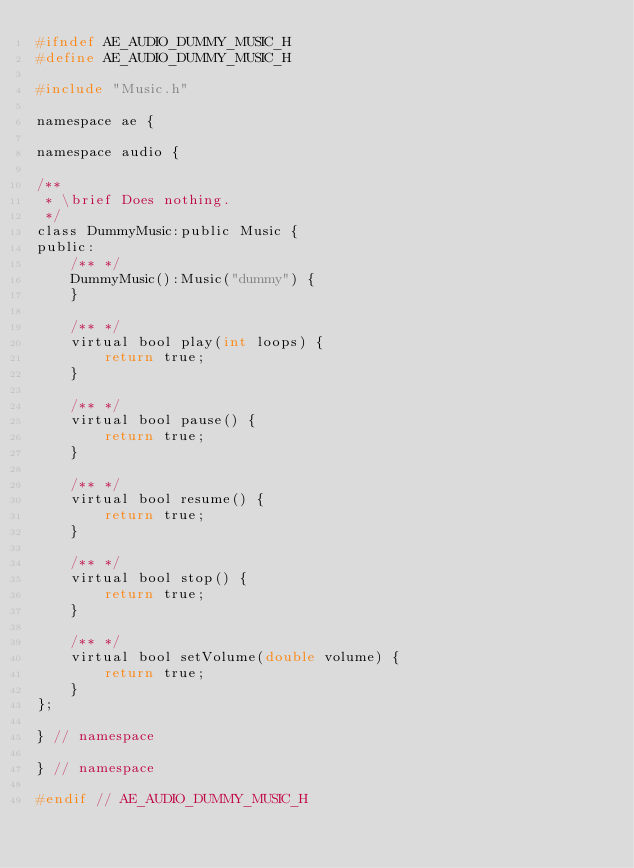<code> <loc_0><loc_0><loc_500><loc_500><_C_>#ifndef AE_AUDIO_DUMMY_MUSIC_H
#define AE_AUDIO_DUMMY_MUSIC_H

#include "Music.h"

namespace ae {

namespace audio {
  
/**
 * \brief Does nothing.
 */
class DummyMusic:public Music {
public:
    /** */
    DummyMusic():Music("dummy") {
    }
    
    /** */
    virtual bool play(int loops) {
        return true;
    }
    
    /** */
    virtual bool pause() {
        return true;
    }
    
    /** */
    virtual bool resume() {
        return true;
    }
    
    /** */
    virtual bool stop() {
        return true;
    }
    
    /** */
    virtual bool setVolume(double volume) {
        return true;
    }
};
    
} // namespace
    
} // namespace

#endif // AE_AUDIO_DUMMY_MUSIC_H</code> 